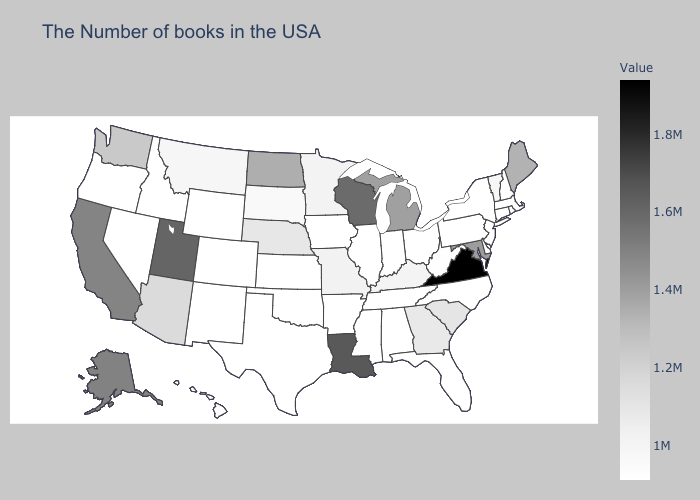Among the states that border Wisconsin , does Minnesota have the highest value?
Write a very short answer. No. Does Missouri have the highest value in the USA?
Concise answer only. No. Does the map have missing data?
Short answer required. No. 